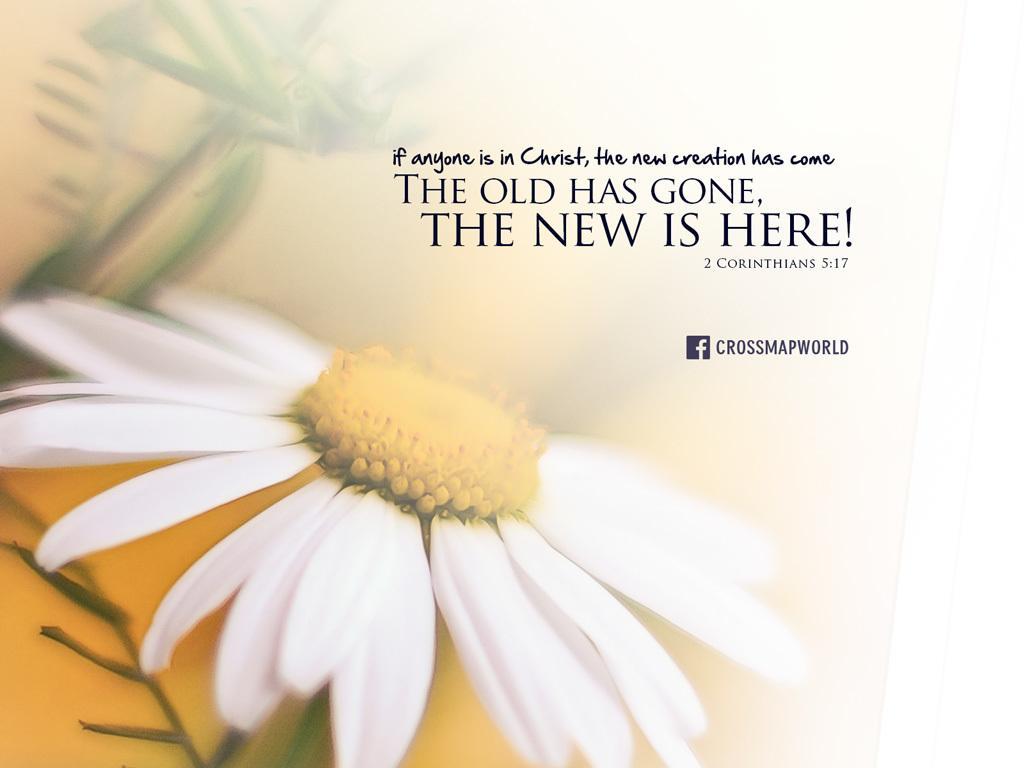Describe this image in one or two sentences. In this image we can see a poster with some text and a white color flower on it. 